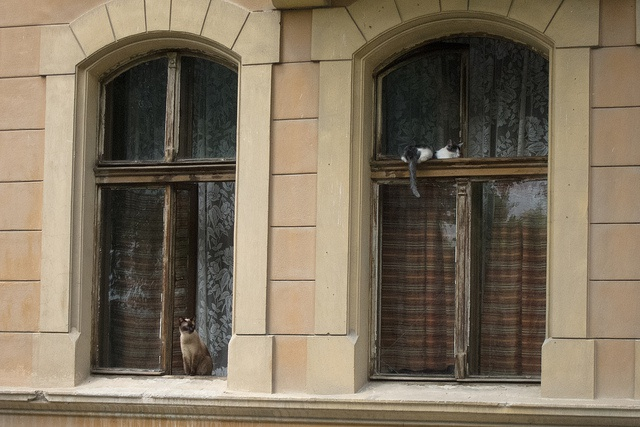Describe the objects in this image and their specific colors. I can see cat in tan, black, gray, and maroon tones and cat in tan, black, gray, darkgray, and lightgray tones in this image. 